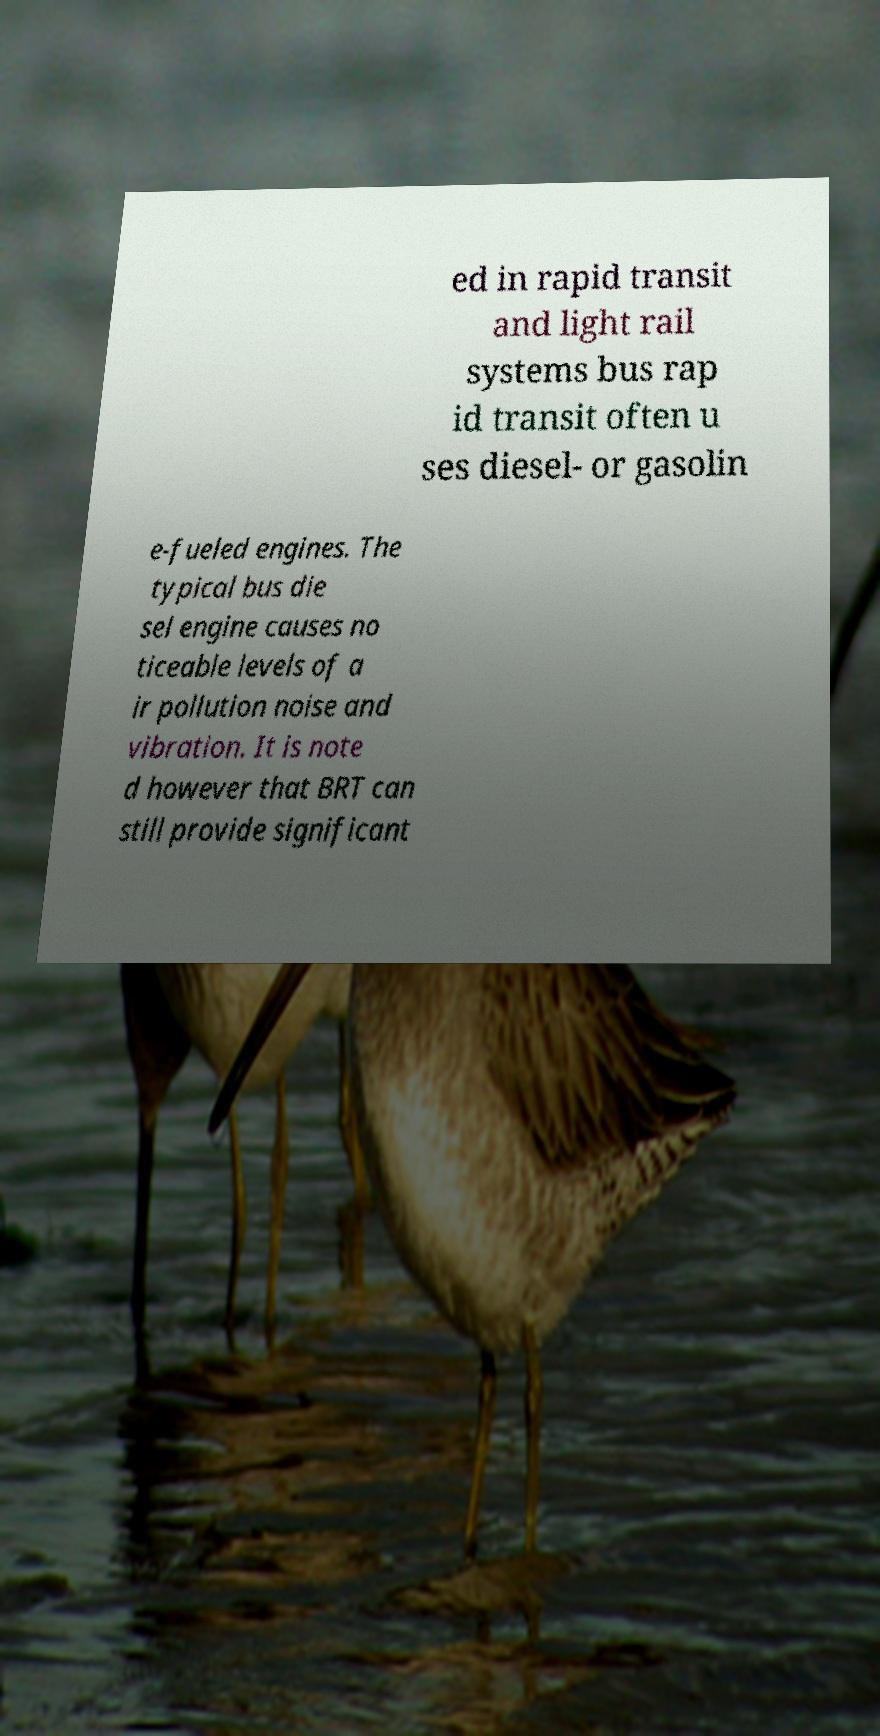Could you extract and type out the text from this image? ed in rapid transit and light rail systems bus rap id transit often u ses diesel- or gasolin e-fueled engines. The typical bus die sel engine causes no ticeable levels of a ir pollution noise and vibration. It is note d however that BRT can still provide significant 